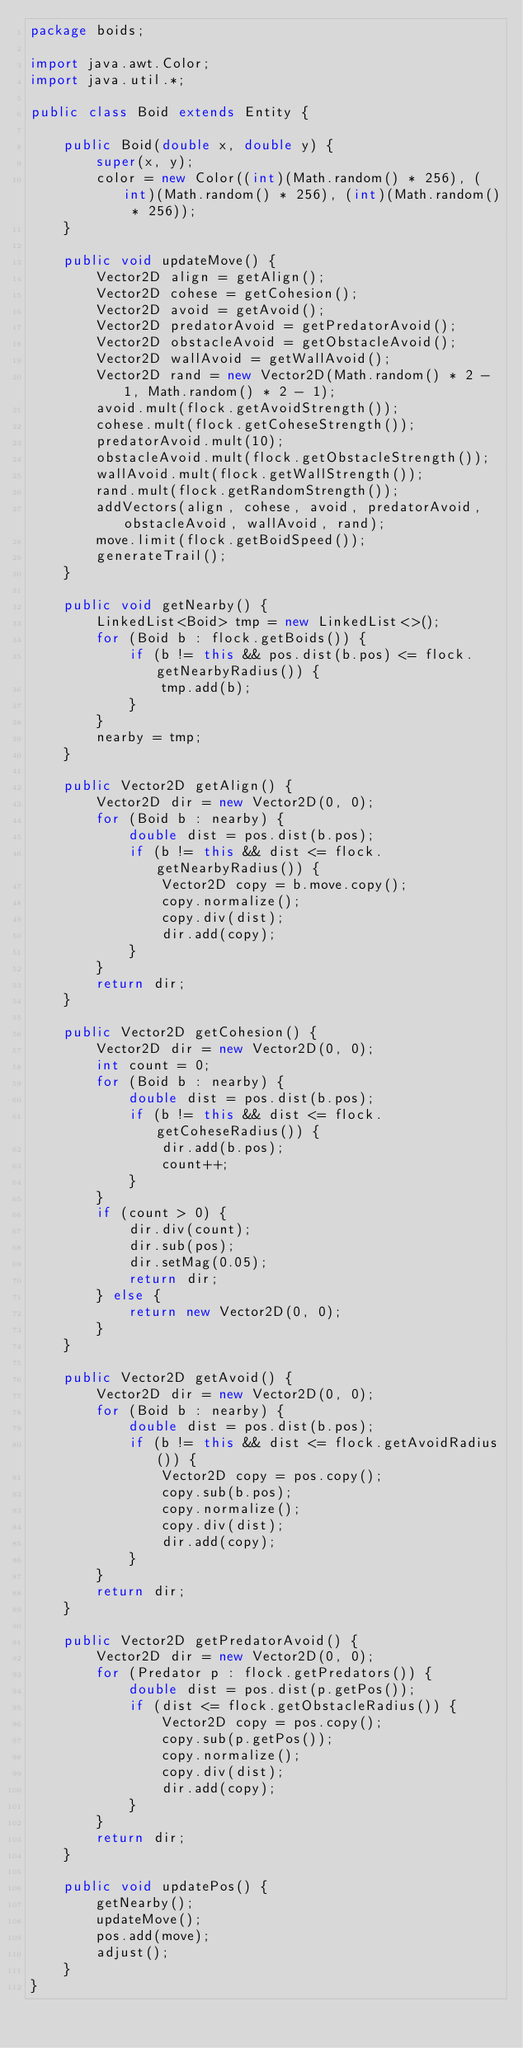<code> <loc_0><loc_0><loc_500><loc_500><_Java_>package boids;

import java.awt.Color;
import java.util.*;

public class Boid extends Entity {

    public Boid(double x, double y) {
        super(x, y);
        color = new Color((int)(Math.random() * 256), (int)(Math.random() * 256), (int)(Math.random() * 256));
    }

    public void updateMove() {
        Vector2D align = getAlign();
        Vector2D cohese = getCohesion();
        Vector2D avoid = getAvoid();
        Vector2D predatorAvoid = getPredatorAvoid();
        Vector2D obstacleAvoid = getObstacleAvoid();
        Vector2D wallAvoid = getWallAvoid();
        Vector2D rand = new Vector2D(Math.random() * 2 - 1, Math.random() * 2 - 1);
        avoid.mult(flock.getAvoidStrength());
        cohese.mult(flock.getCoheseStrength());
        predatorAvoid.mult(10);
        obstacleAvoid.mult(flock.getObstacleStrength());
        wallAvoid.mult(flock.getWallStrength());
        rand.mult(flock.getRandomStrength());
        addVectors(align, cohese, avoid, predatorAvoid, obstacleAvoid, wallAvoid, rand);
        move.limit(flock.getBoidSpeed());
        generateTrail();
    }
    
    public void getNearby() {
        LinkedList<Boid> tmp = new LinkedList<>();
        for (Boid b : flock.getBoids()) {
            if (b != this && pos.dist(b.pos) <= flock.getNearbyRadius()) {
                tmp.add(b);
            }
        }
        nearby = tmp;
    }

    public Vector2D getAlign() {
        Vector2D dir = new Vector2D(0, 0);
        for (Boid b : nearby) {
            double dist = pos.dist(b.pos);
            if (b != this && dist <= flock.getNearbyRadius()) {
                Vector2D copy = b.move.copy();
                copy.normalize();
                copy.div(dist);
                dir.add(copy);
            }
        }
        return dir;
    }

    public Vector2D getCohesion() {
        Vector2D dir = new Vector2D(0, 0);
        int count = 0;
        for (Boid b : nearby) {
            double dist = pos.dist(b.pos);
            if (b != this && dist <= flock.getCoheseRadius()) {
                dir.add(b.pos);
                count++;
            }
        }
        if (count > 0) {
            dir.div(count);
            dir.sub(pos);
            dir.setMag(0.05);
            return dir;
        } else {
            return new Vector2D(0, 0);
        }
    }

    public Vector2D getAvoid() {
        Vector2D dir = new Vector2D(0, 0);
        for (Boid b : nearby) {
            double dist = pos.dist(b.pos);
            if (b != this && dist <= flock.getAvoidRadius()) {
                Vector2D copy = pos.copy();
                copy.sub(b.pos);
                copy.normalize();
                copy.div(dist);
                dir.add(copy);
            }
        }
        return dir;
    }

    public Vector2D getPredatorAvoid() {
        Vector2D dir = new Vector2D(0, 0);
        for (Predator p : flock.getPredators()) {
            double dist = pos.dist(p.getPos());
            if (dist <= flock.getObstacleRadius()) {
                Vector2D copy = pos.copy();
                copy.sub(p.getPos());
                copy.normalize();
                copy.div(dist);
                dir.add(copy);
            }
        }
        return dir;
    }

    public void updatePos() {
        getNearby();
        updateMove();
        pos.add(move);
        adjust();
    }
}
</code> 